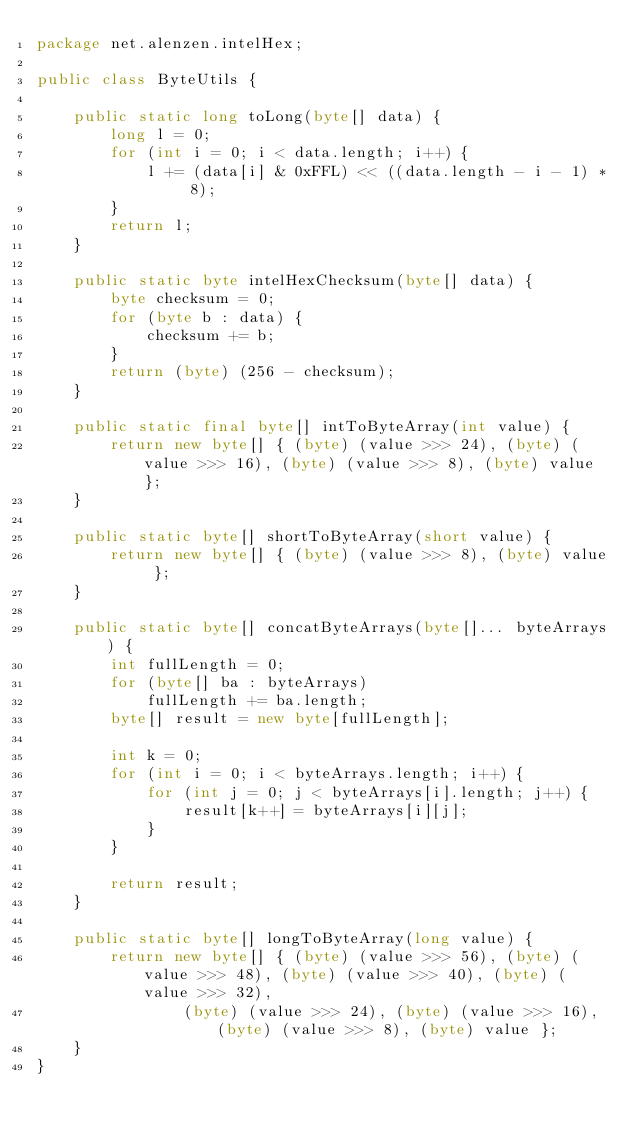<code> <loc_0><loc_0><loc_500><loc_500><_Java_>package net.alenzen.intelHex;

public class ByteUtils {

	public static long toLong(byte[] data) {
		long l = 0;
		for (int i = 0; i < data.length; i++) {
			l += (data[i] & 0xFFL) << ((data.length - i - 1) * 8);
		}
		return l;
	}

	public static byte intelHexChecksum(byte[] data) {
		byte checksum = 0;
		for (byte b : data) {
			checksum += b;
		}
		return (byte) (256 - checksum);
	}

	public static final byte[] intToByteArray(int value) {
		return new byte[] { (byte) (value >>> 24), (byte) (value >>> 16), (byte) (value >>> 8), (byte) value };
	}

	public static byte[] shortToByteArray(short value) {
		return new byte[] { (byte) (value >>> 8), (byte) value };
	}

	public static byte[] concatByteArrays(byte[]... byteArrays) {
		int fullLength = 0;
		for (byte[] ba : byteArrays)
			fullLength += ba.length;
		byte[] result = new byte[fullLength];

		int k = 0;
		for (int i = 0; i < byteArrays.length; i++) {
			for (int j = 0; j < byteArrays[i].length; j++) {
				result[k++] = byteArrays[i][j];
			}
		}

		return result;
	}

	public static byte[] longToByteArray(long value) {
		return new byte[] { (byte) (value >>> 56), (byte) (value >>> 48), (byte) (value >>> 40), (byte) (value >>> 32),
				(byte) (value >>> 24), (byte) (value >>> 16), (byte) (value >>> 8), (byte) value };
	}
}
</code> 